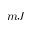<formula> <loc_0><loc_0><loc_500><loc_500>m J</formula> 